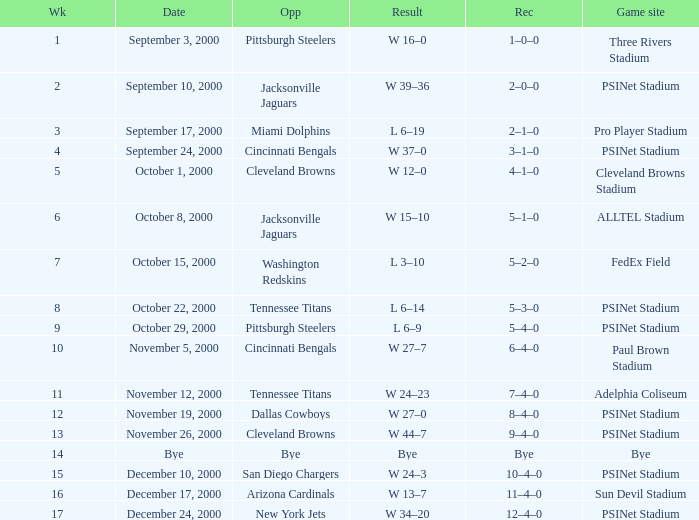What's the record after week 16? 12–4–0. Parse the table in full. {'header': ['Wk', 'Date', 'Opp', 'Result', 'Rec', 'Game site'], 'rows': [['1', 'September 3, 2000', 'Pittsburgh Steelers', 'W 16–0', '1–0–0', 'Three Rivers Stadium'], ['2', 'September 10, 2000', 'Jacksonville Jaguars', 'W 39–36', '2–0–0', 'PSINet Stadium'], ['3', 'September 17, 2000', 'Miami Dolphins', 'L 6–19', '2–1–0', 'Pro Player Stadium'], ['4', 'September 24, 2000', 'Cincinnati Bengals', 'W 37–0', '3–1–0', 'PSINet Stadium'], ['5', 'October 1, 2000', 'Cleveland Browns', 'W 12–0', '4–1–0', 'Cleveland Browns Stadium'], ['6', 'October 8, 2000', 'Jacksonville Jaguars', 'W 15–10', '5–1–0', 'ALLTEL Stadium'], ['7', 'October 15, 2000', 'Washington Redskins', 'L 3–10', '5–2–0', 'FedEx Field'], ['8', 'October 22, 2000', 'Tennessee Titans', 'L 6–14', '5–3–0', 'PSINet Stadium'], ['9', 'October 29, 2000', 'Pittsburgh Steelers', 'L 6–9', '5–4–0', 'PSINet Stadium'], ['10', 'November 5, 2000', 'Cincinnati Bengals', 'W 27–7', '6–4–0', 'Paul Brown Stadium'], ['11', 'November 12, 2000', 'Tennessee Titans', 'W 24–23', '7–4–0', 'Adelphia Coliseum'], ['12', 'November 19, 2000', 'Dallas Cowboys', 'W 27–0', '8–4–0', 'PSINet Stadium'], ['13', 'November 26, 2000', 'Cleveland Browns', 'W 44–7', '9–4–0', 'PSINet Stadium'], ['14', 'Bye', 'Bye', 'Bye', 'Bye', 'Bye'], ['15', 'December 10, 2000', 'San Diego Chargers', 'W 24–3', '10–4–0', 'PSINet Stadium'], ['16', 'December 17, 2000', 'Arizona Cardinals', 'W 13–7', '11–4–0', 'Sun Devil Stadium'], ['17', 'December 24, 2000', 'New York Jets', 'W 34–20', '12–4–0', 'PSINet Stadium']]} 